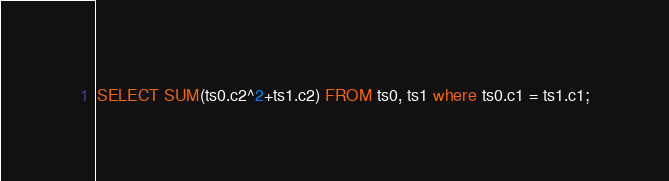Convert code to text. <code><loc_0><loc_0><loc_500><loc_500><_SQL_>SELECT SUM(ts0.c2^2+ts1.c2) FROM ts0, ts1 where ts0.c1 = ts1.c1;
</code> 